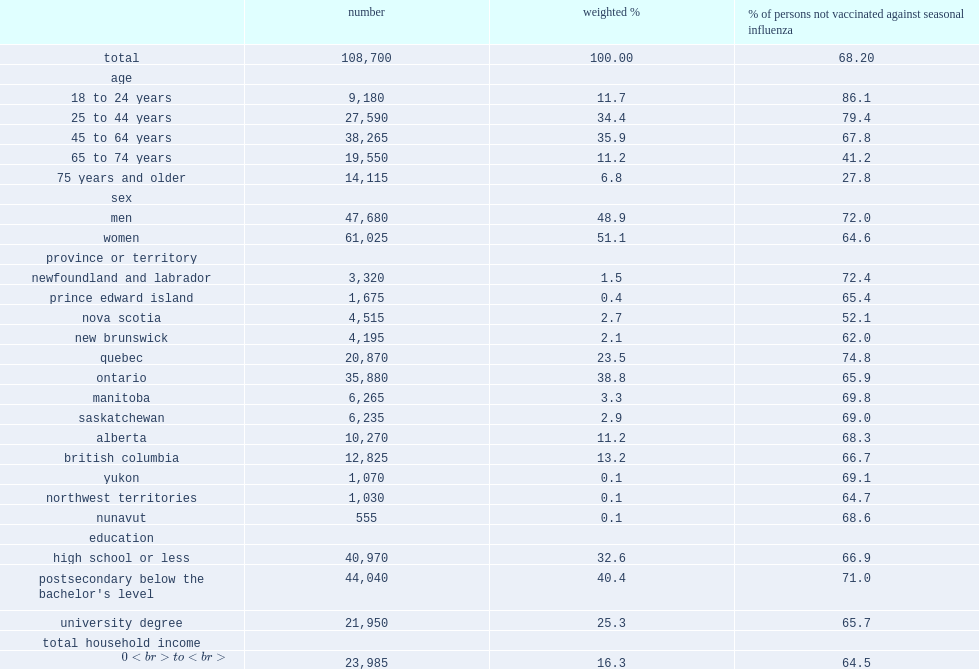How many respondents are included in the analyses? 108700.0. 